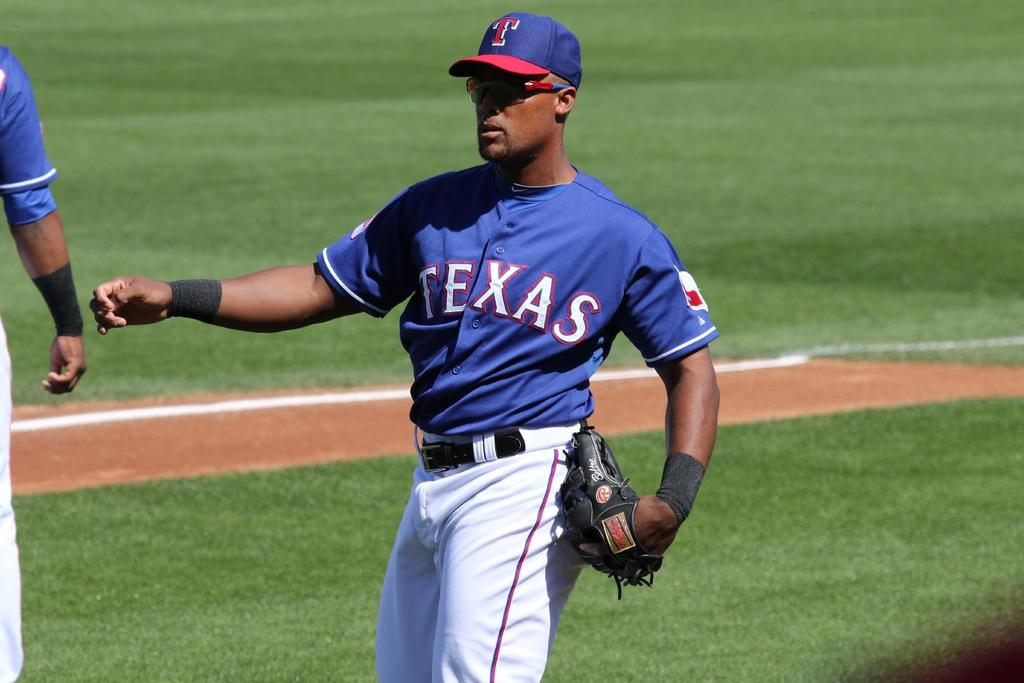<image>
Render a clear and concise summary of the photo. The blue uniform says the word Texas on the front of it 